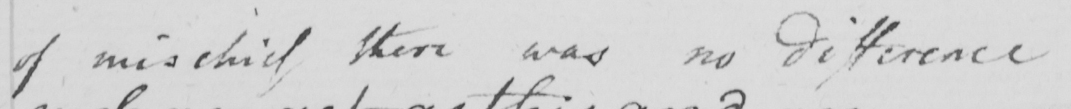Transcribe the text shown in this historical manuscript line. of mischief there was no difference 